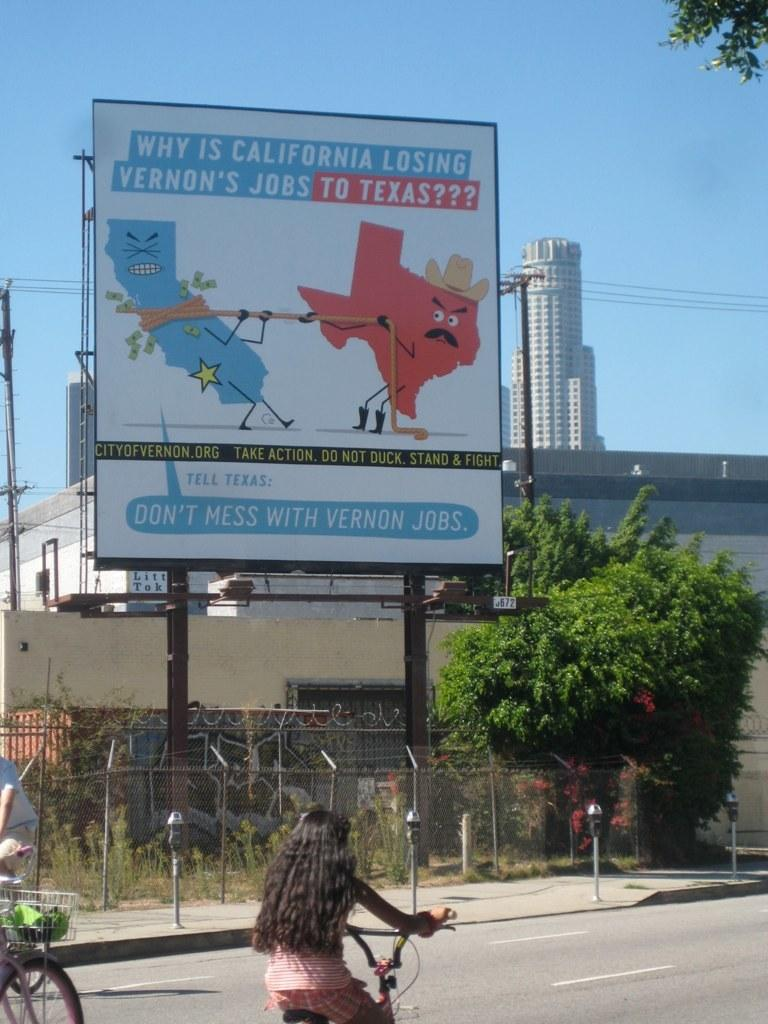<image>
Provide a brief description of the given image. A billboard for Vernon Jobs shows the states California and Texas playing a tug of war with the words "stand and fight" beneath 